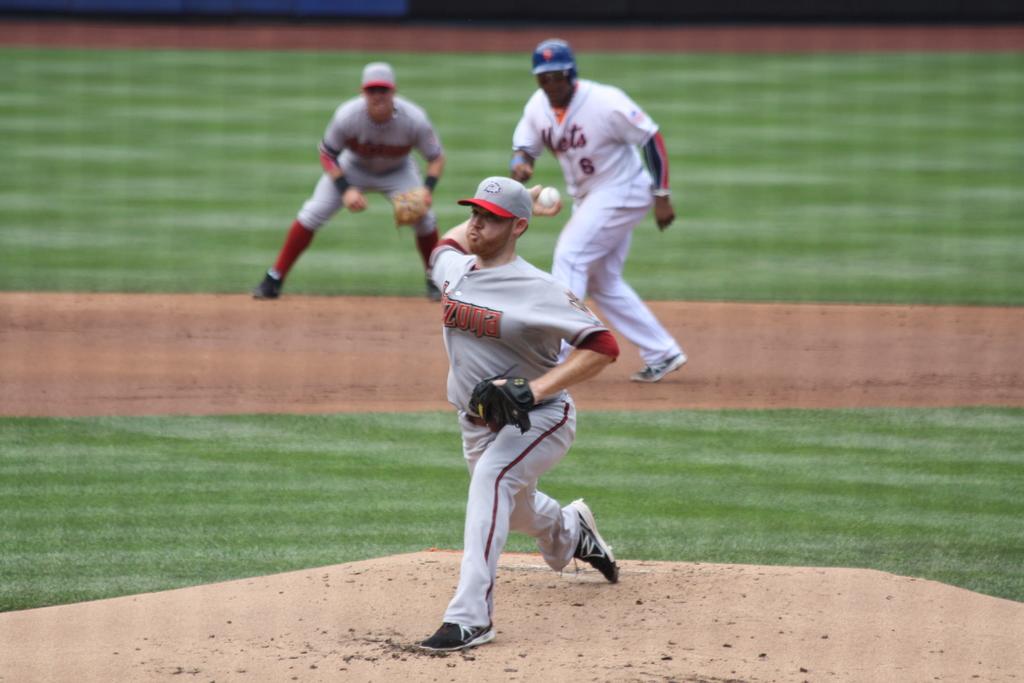What is the jersey number of the mets player?
Your response must be concise. 6. What is the jersey number of the running in the middle?
Make the answer very short. 6. 